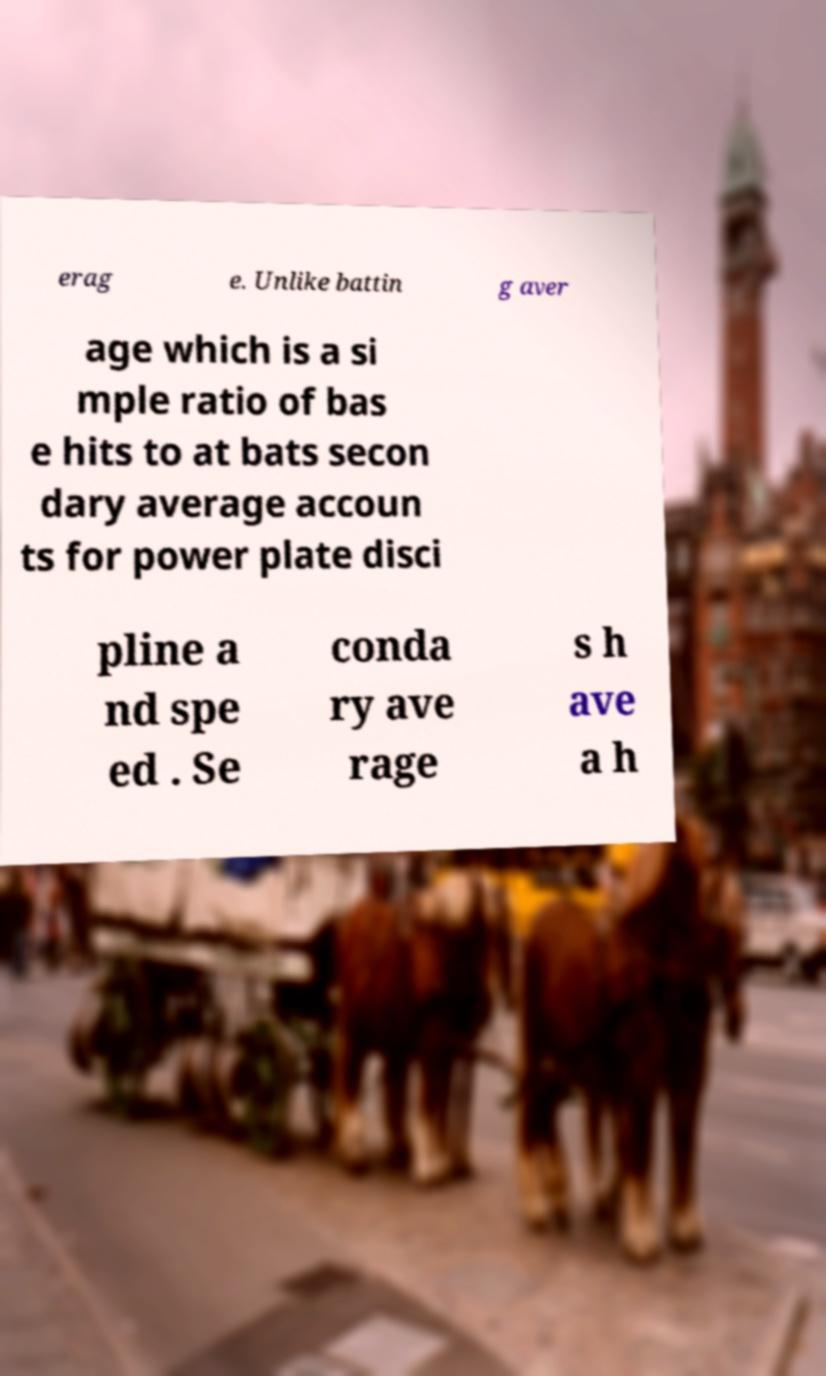Please identify and transcribe the text found in this image. erag e. Unlike battin g aver age which is a si mple ratio of bas e hits to at bats secon dary average accoun ts for power plate disci pline a nd spe ed . Se conda ry ave rage s h ave a h 